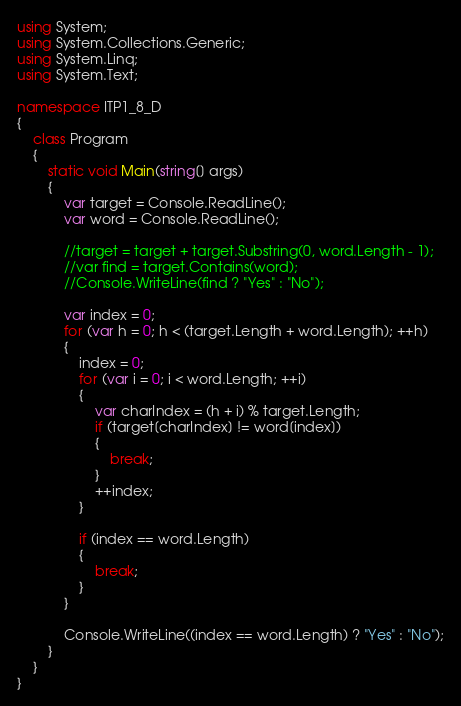Convert code to text. <code><loc_0><loc_0><loc_500><loc_500><_C#_>using System;
using System.Collections.Generic;
using System.Linq;
using System.Text;

namespace ITP1_8_D
{
    class Program
    {
        static void Main(string[] args)
        {
            var target = Console.ReadLine();
            var word = Console.ReadLine();

            //target = target + target.Substring(0, word.Length - 1);
            //var find = target.Contains(word);
            //Console.WriteLine(find ? "Yes" : "No");

            var index = 0;
            for (var h = 0; h < (target.Length + word.Length); ++h)
            {
                index = 0;
                for (var i = 0; i < word.Length; ++i)
                {
                    var charIndex = (h + i) % target.Length;
                    if (target[charIndex] != word[index])
                    {
                        break;
                    }
                    ++index;
                }

                if (index == word.Length)
                {
                    break;
                }
            }

            Console.WriteLine((index == word.Length) ? "Yes" : "No");
        }
    }
}</code> 